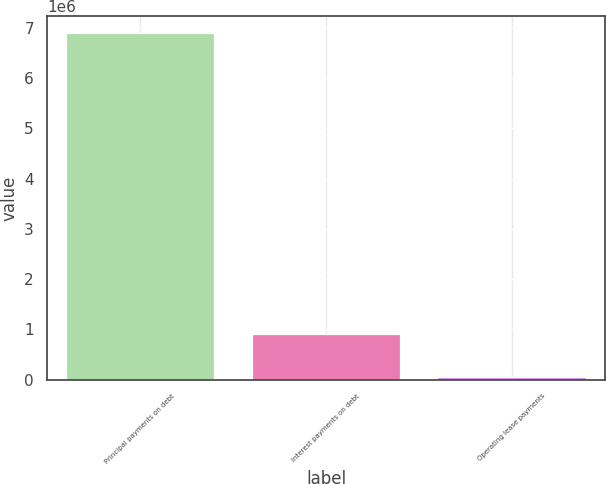Convert chart to OTSL. <chart><loc_0><loc_0><loc_500><loc_500><bar_chart><fcel>Principal payments on debt<fcel>Interest payments on debt<fcel>Operating lease payments<nl><fcel>6.89039e+06<fcel>910818<fcel>55529<nl></chart> 